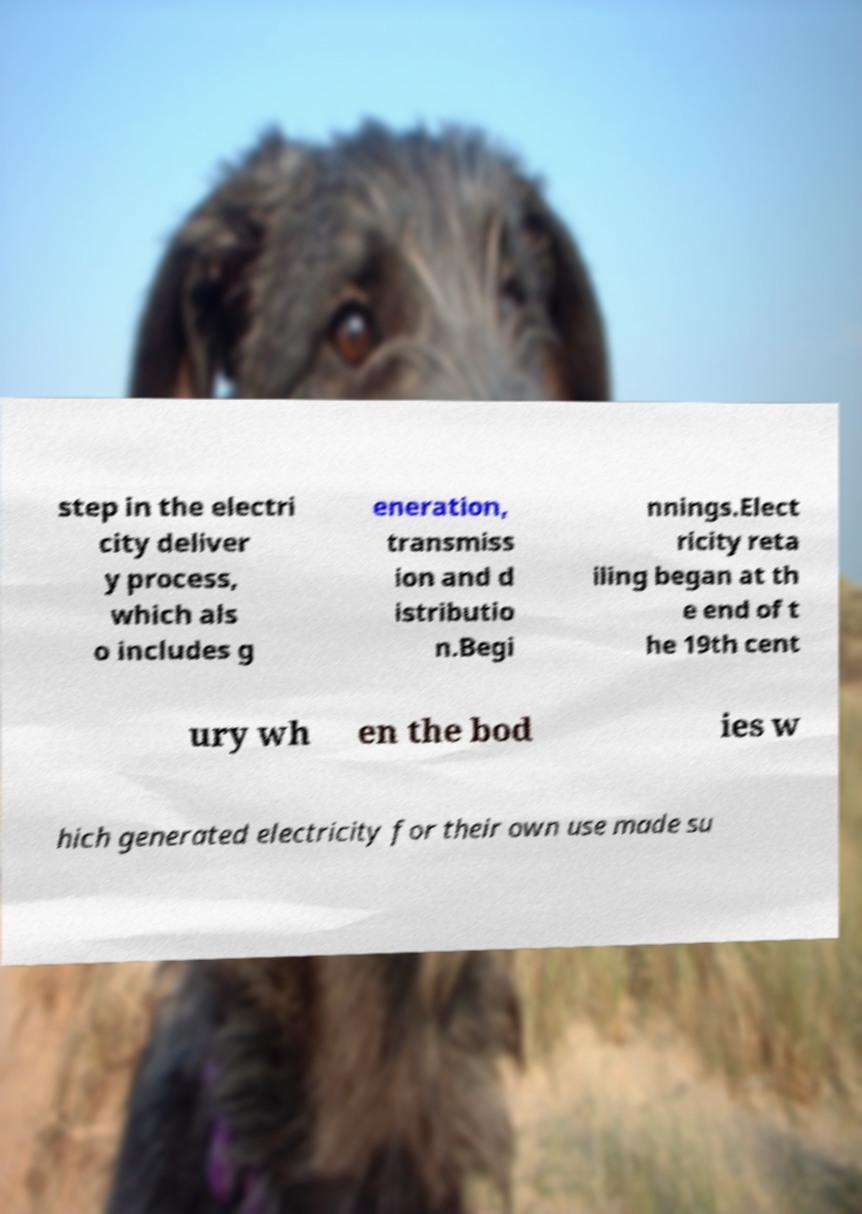For documentation purposes, I need the text within this image transcribed. Could you provide that? step in the electri city deliver y process, which als o includes g eneration, transmiss ion and d istributio n.Begi nnings.Elect ricity reta iling began at th e end of t he 19th cent ury wh en the bod ies w hich generated electricity for their own use made su 